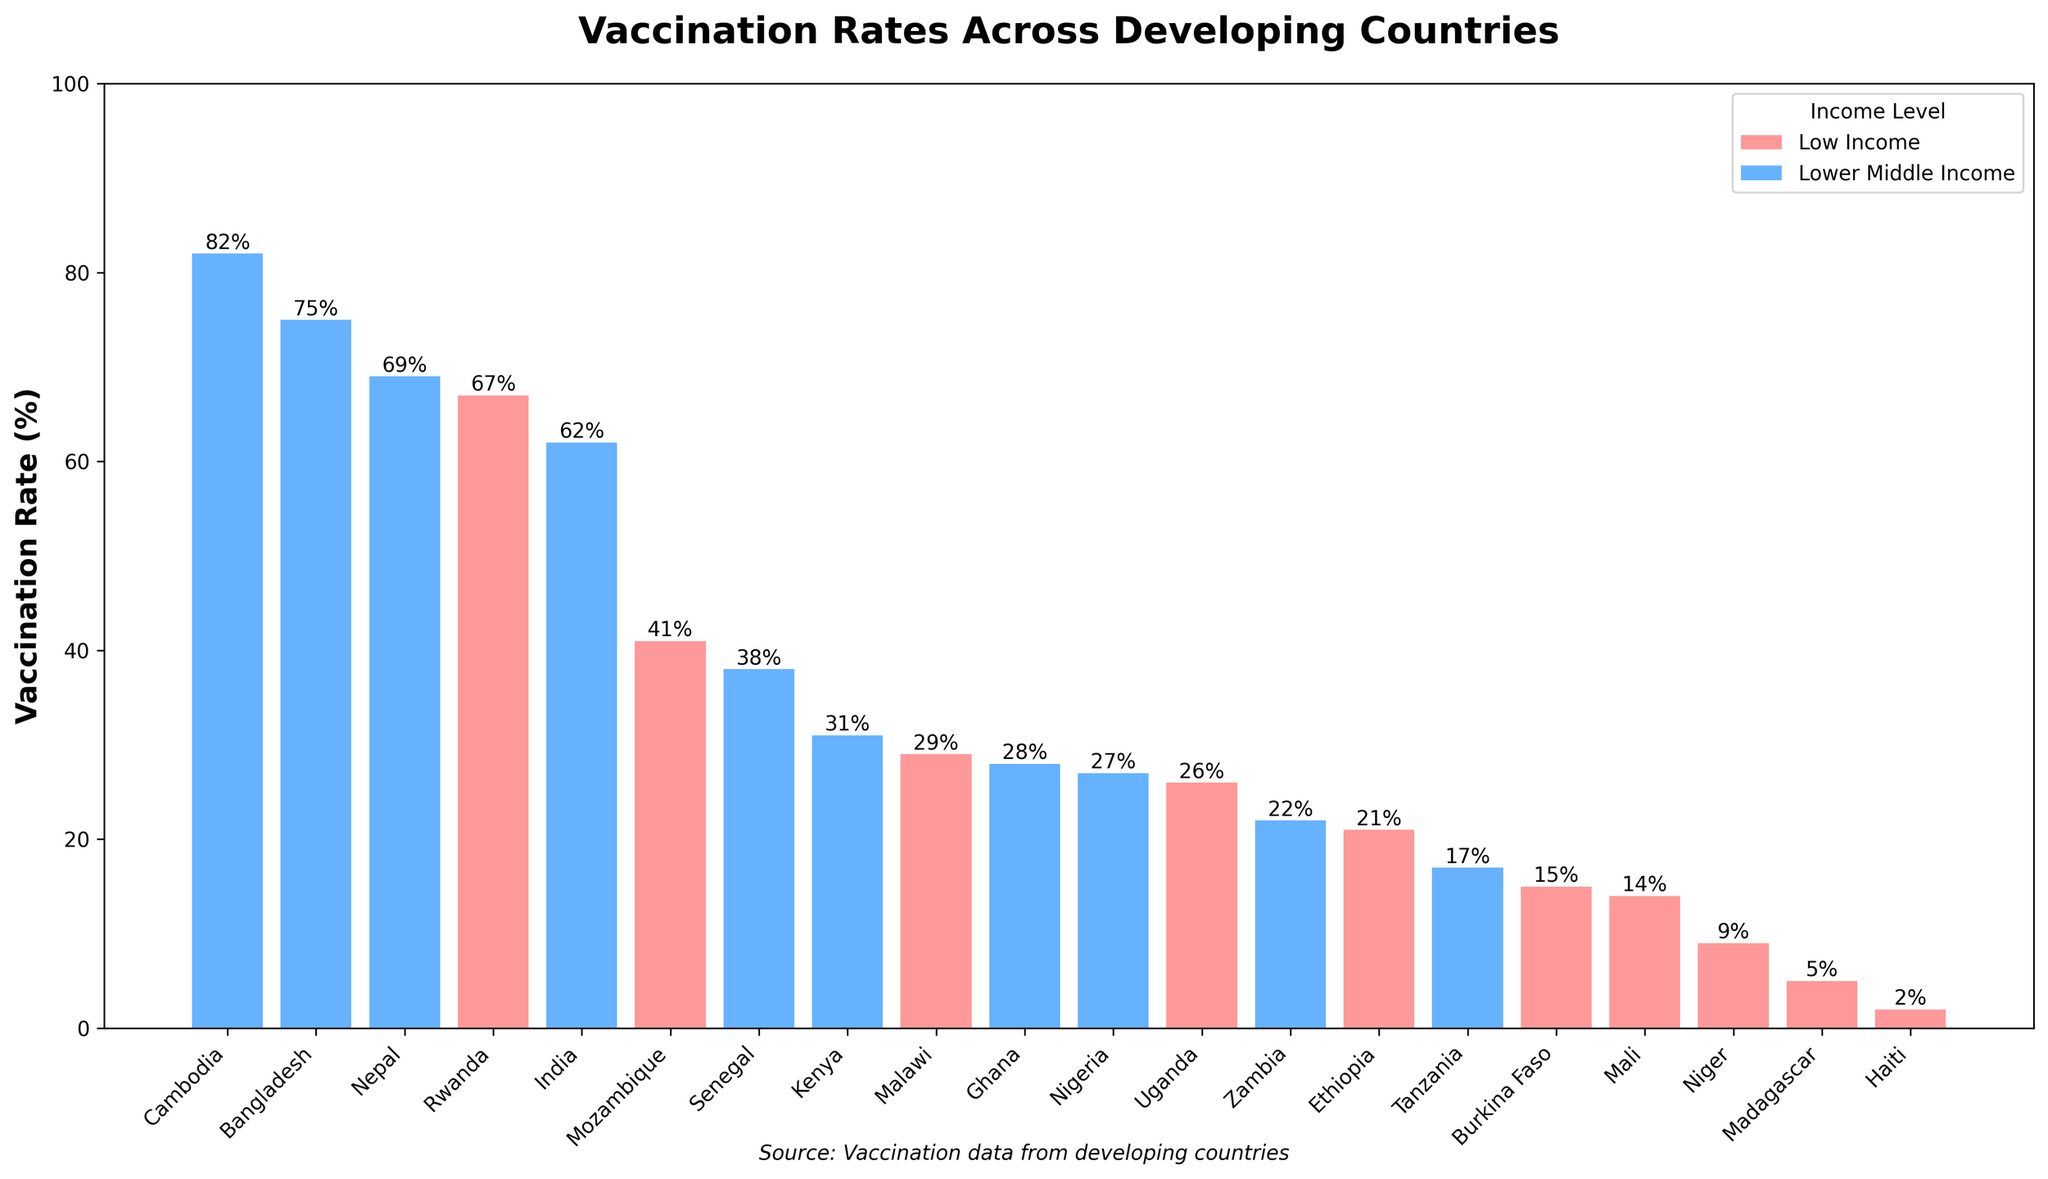What is the overall trend in vaccination rates between low-income and lower-middle-income countries? From the bar chart, it's apparent that lower-middle-income countries tend to have higher vaccination rates compared to low-income countries. For example, countries like Cambodia and Bangladesh have rates above 75%, while most low-income countries have rates below 50%. The visual color differentiation between red (low income) and blue (lower middle income) helps illustrate this trend.
Answer: Lower-middle-income countries generally have higher vaccination rates than low-income countries Which country has the highest vaccination rate? The height of the bars on the chart shows that Cambodia, marked in blue, has the highest vaccination rate among the listed countries. Its bar is the tallest, indicating a vaccination rate of 82%.
Answer: Cambodia How does India's vaccination rate compare to Ethiopia's? By comparing the heights of the bars for India and Ethiopia, it is clear that India's bar is significantly taller. The vaccination rate for India is marked at 62%, while Ethiopia's rate is only 21%.
Answer: India's vaccination rate is higher than Ethiopia's What is the average vaccination rate for the two countries with the lowest rates? The countries with the lowest vaccination rates are Haiti and Madagascar, with rates of 2% and 5%, respectively. To find the average, we sum 2 + 5 = 7 and divide by 2: 7 / 2 = 3.5%.
Answer: 3.5% Which low-income country has the highest vaccination rate? The tallest bar among the red-colored (low-income) countries is for Rwanda, showing a vaccination rate of 67%.
Answer: Rwanda What is the median vaccination rate among lower-middle-income countries? To find the median, we first list the lower-middle-income countries' rates in ascending order: 17, 22, 27, 28, 31, 38, 62, 69, 75, 82. With 10 data points, the median will be the average of the 5th and 6th values (31 and 38). Thus, (31 + 38) / 2 = 34.5%.
Answer: 34.5% How many countries have a vaccination rate above 50%? Looking at the chart, the bars taller than 50% are for India, Bangladesh, Nepal, Cambodia, and Rwanda. Counting these reveals there are 5 such countries.
Answer: 5 Which income level has more countries with vaccination rates below 30%? By observing the bars under 30%, we see the countries are Ethiopia, Tanzania, Uganda, Mali, Haiti, Burkina Faso, Madagascar, and Niger. 7 of these countries belong to the low-income group (red), while 1 belongs to the lower-middle-income group (blue).
Answer: Low-income level What is the total vaccination rate for Nigeria and Ghana? Nigeria has a vaccination rate of 27% and Ghana has 28%. Adding these together, 27 + 28 = 55%.
Answer: 55% If we were to rank the countries by vaccination rate, what rank does Mozambique hold? Sorting the countries by vaccination rate yields: Cambodia, Bangladesh, Nepal, Rwanda, India, Mozambique, Senegal, Kenya, Ghana, Nigeria, Malawi, Uganda, Zambia, Ethiopia, Burkina Faso, Tanzania, Mali, Madagascar, Niger, Haiti. Mozambique holds the 6th position.
Answer: 6th 